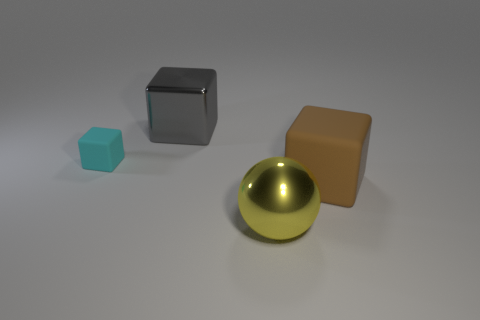How many other things are there of the same size as the cyan object?
Offer a very short reply. 0. Do the small thing and the large sphere have the same color?
Your answer should be very brief. No. The large brown thing that is right of the large shiny thing on the left side of the large yellow metallic ball that is in front of the small cube is what shape?
Your response must be concise. Cube. How many things are either things right of the small thing or large things that are in front of the big matte block?
Your answer should be very brief. 3. How big is the rubber cube that is to the left of the large shiny object to the right of the large metal cube?
Provide a short and direct response. Small. There is a big metal object behind the large rubber object; is its color the same as the small cube?
Provide a succinct answer. No. Is there a big gray thing that has the same shape as the cyan matte thing?
Your answer should be very brief. Yes. What is the color of the metallic sphere that is the same size as the gray object?
Your response must be concise. Yellow. There is a cube that is to the right of the big yellow thing; how big is it?
Provide a short and direct response. Large. Is there a small cyan matte thing that is to the right of the cube that is on the right side of the metal cube?
Your response must be concise. No. 